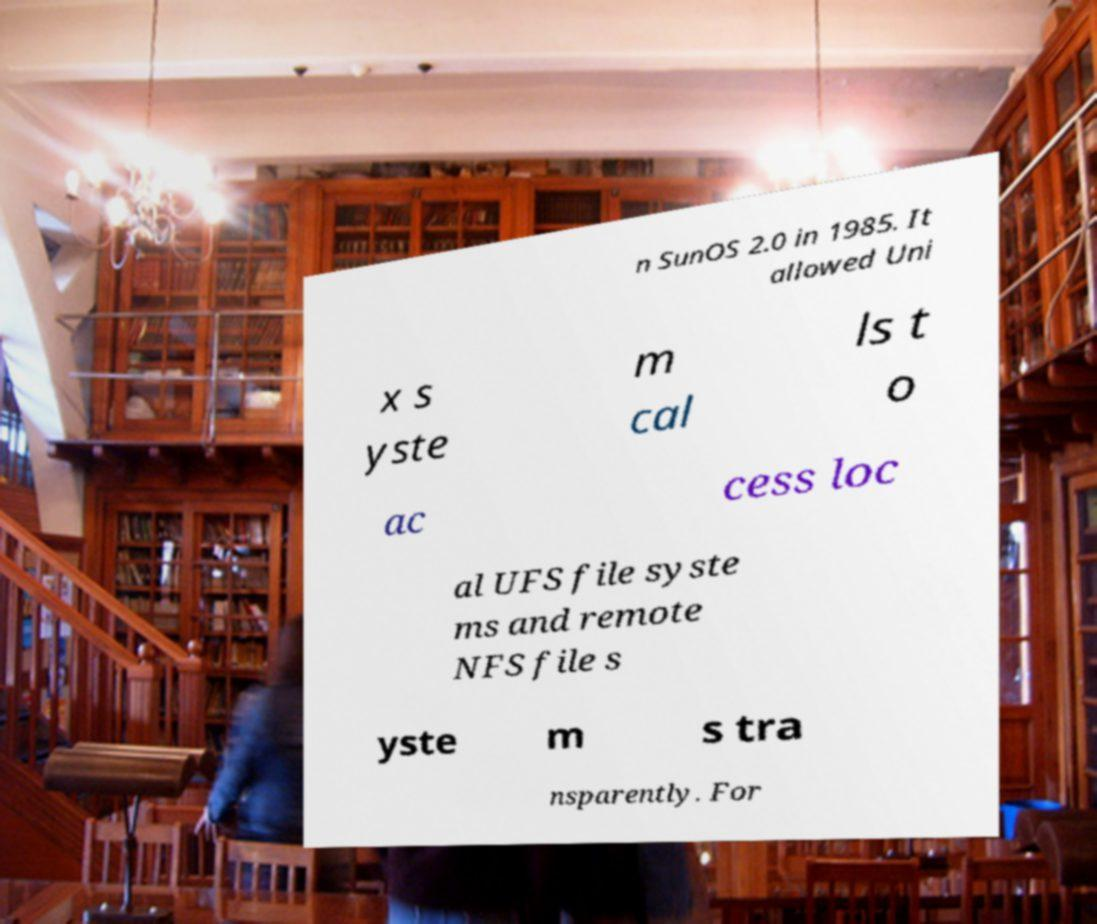For documentation purposes, I need the text within this image transcribed. Could you provide that? n SunOS 2.0 in 1985. It allowed Uni x s yste m cal ls t o ac cess loc al UFS file syste ms and remote NFS file s yste m s tra nsparently. For 